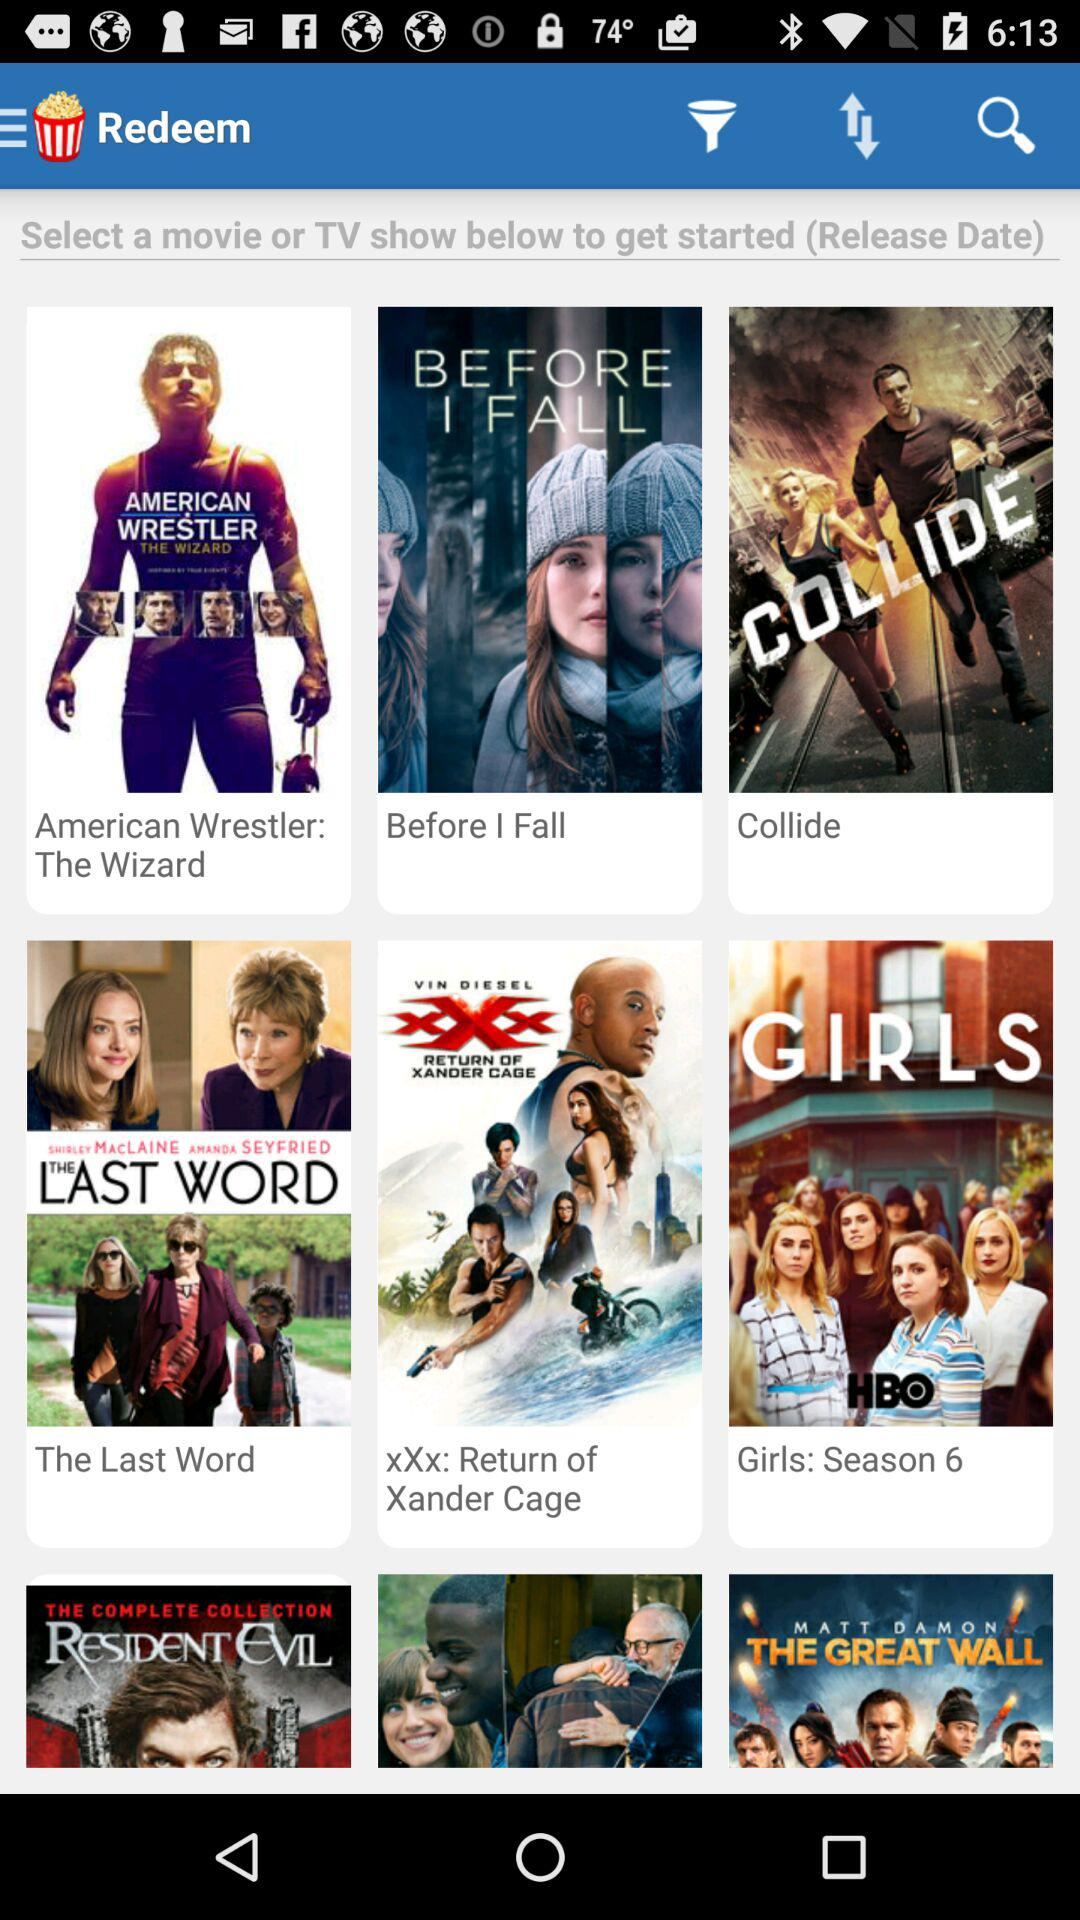What is the name of the application? The application name is "Redeem". 